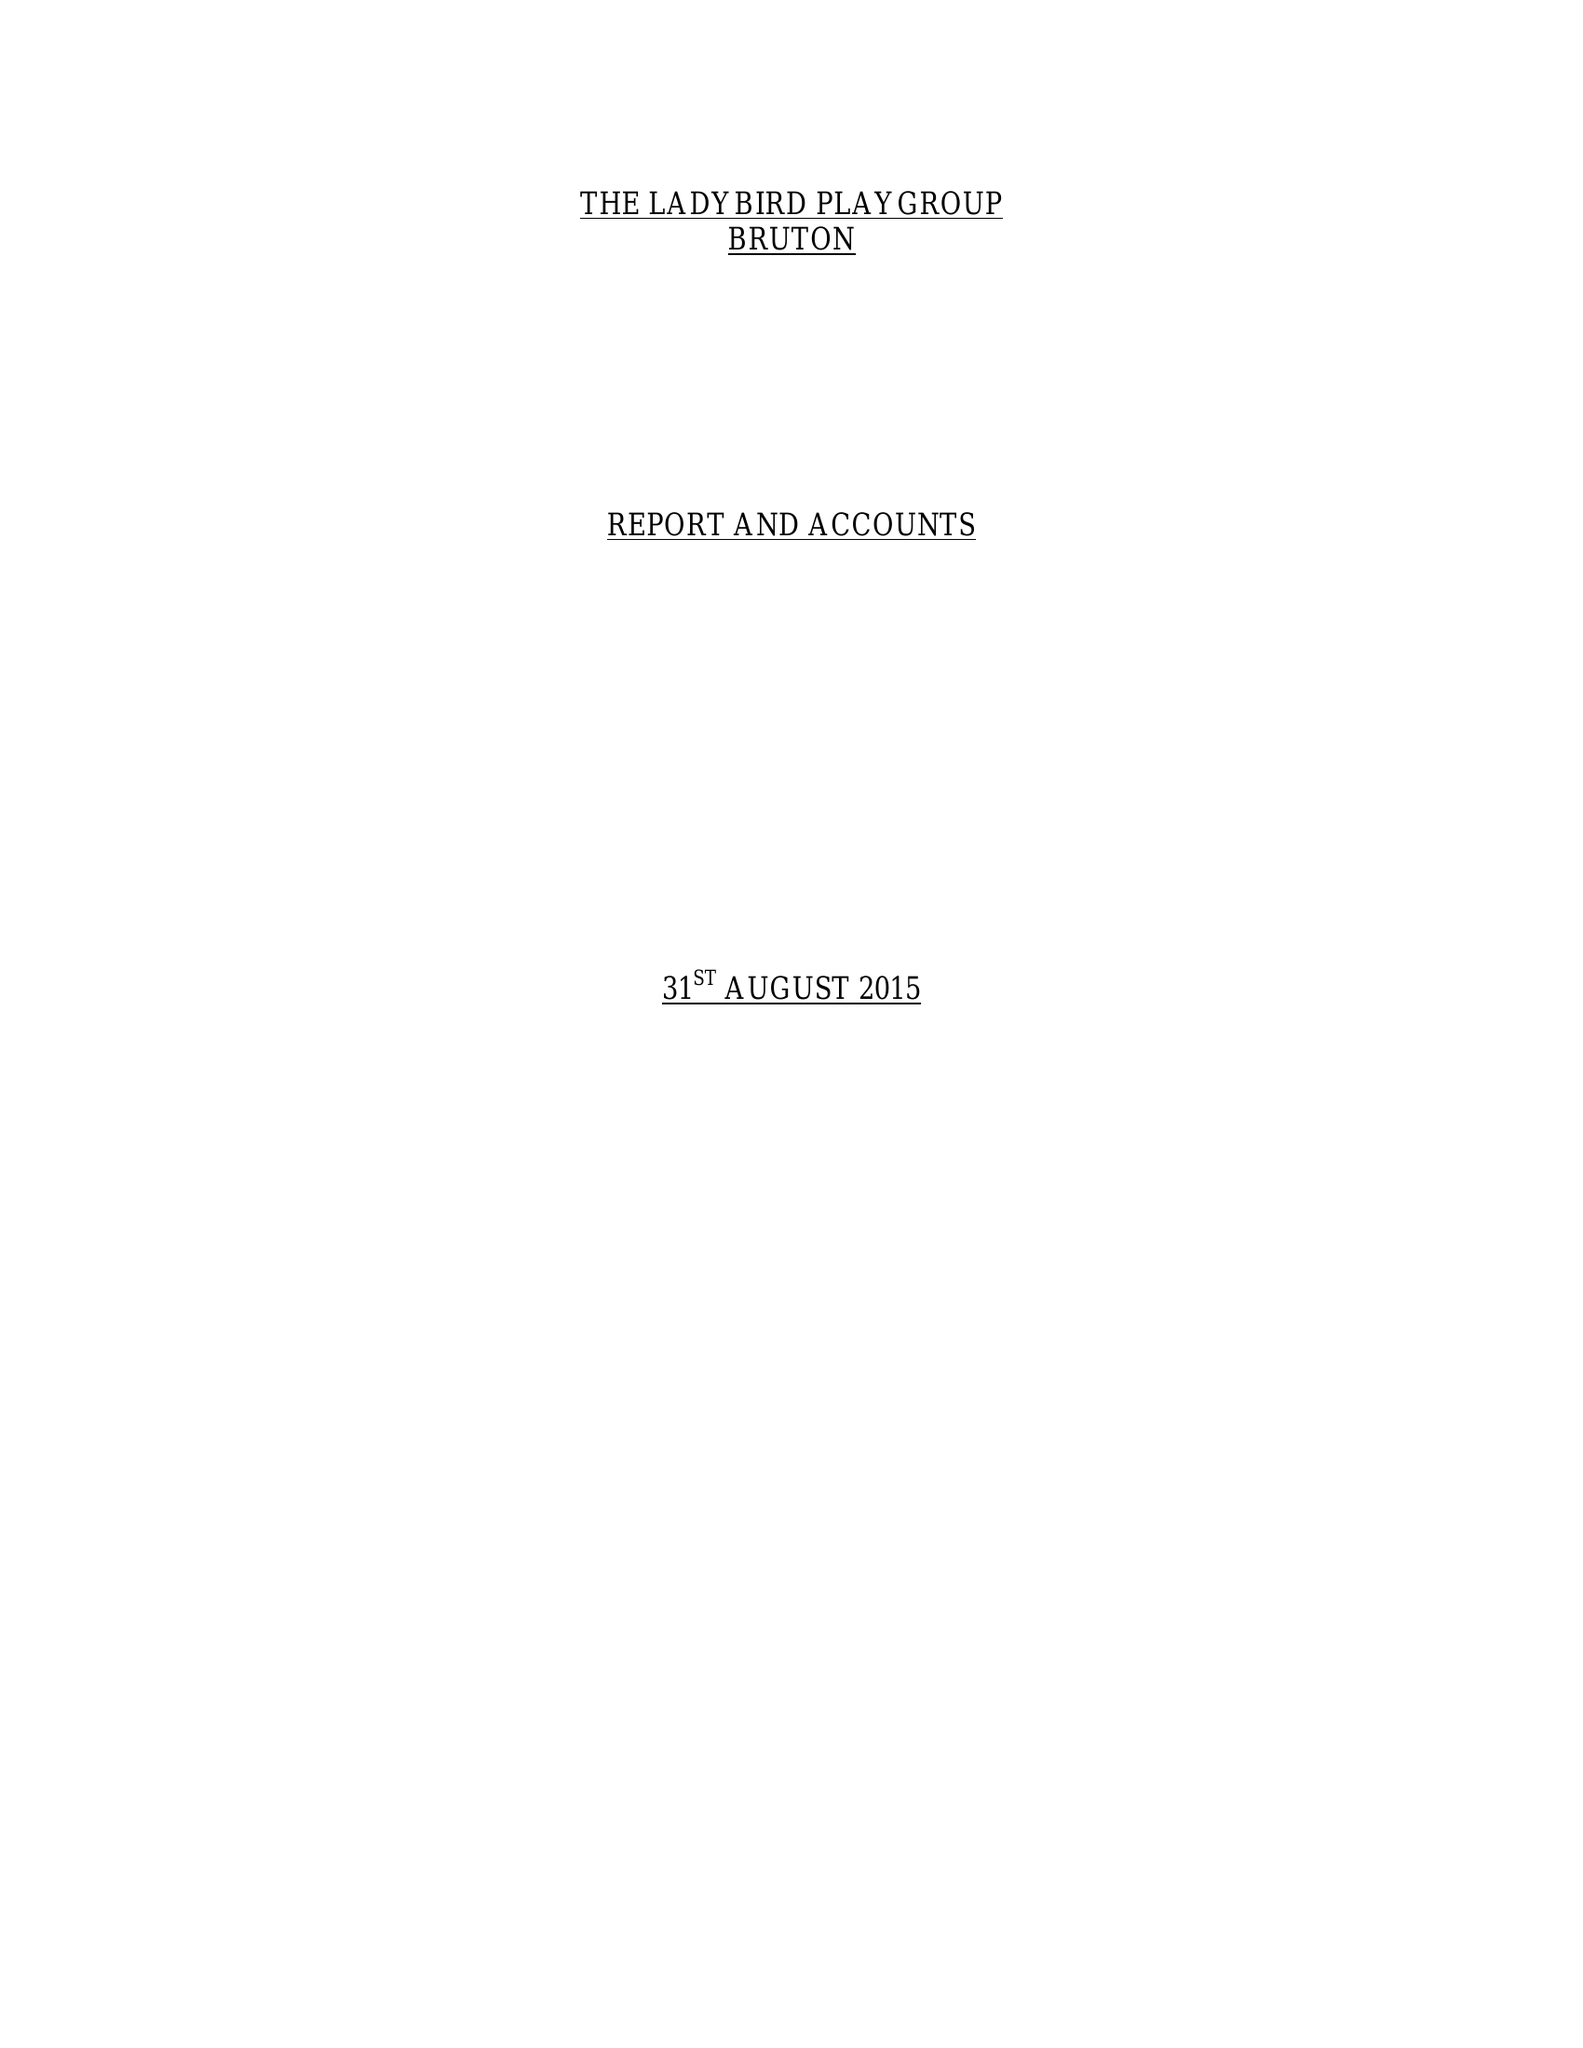What is the value for the charity_name?
Answer the question using a single word or phrase. Ladybird Playgroup 